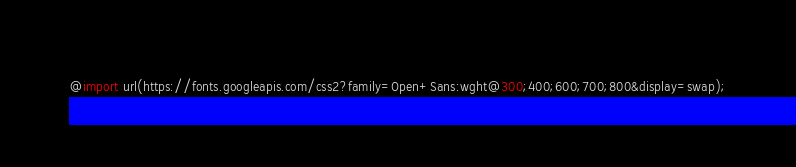Convert code to text. <code><loc_0><loc_0><loc_500><loc_500><_CSS_>@import url(https://fonts.googleapis.com/css2?family=Open+Sans:wght@300;400;600;700;800&display=swap);</code> 